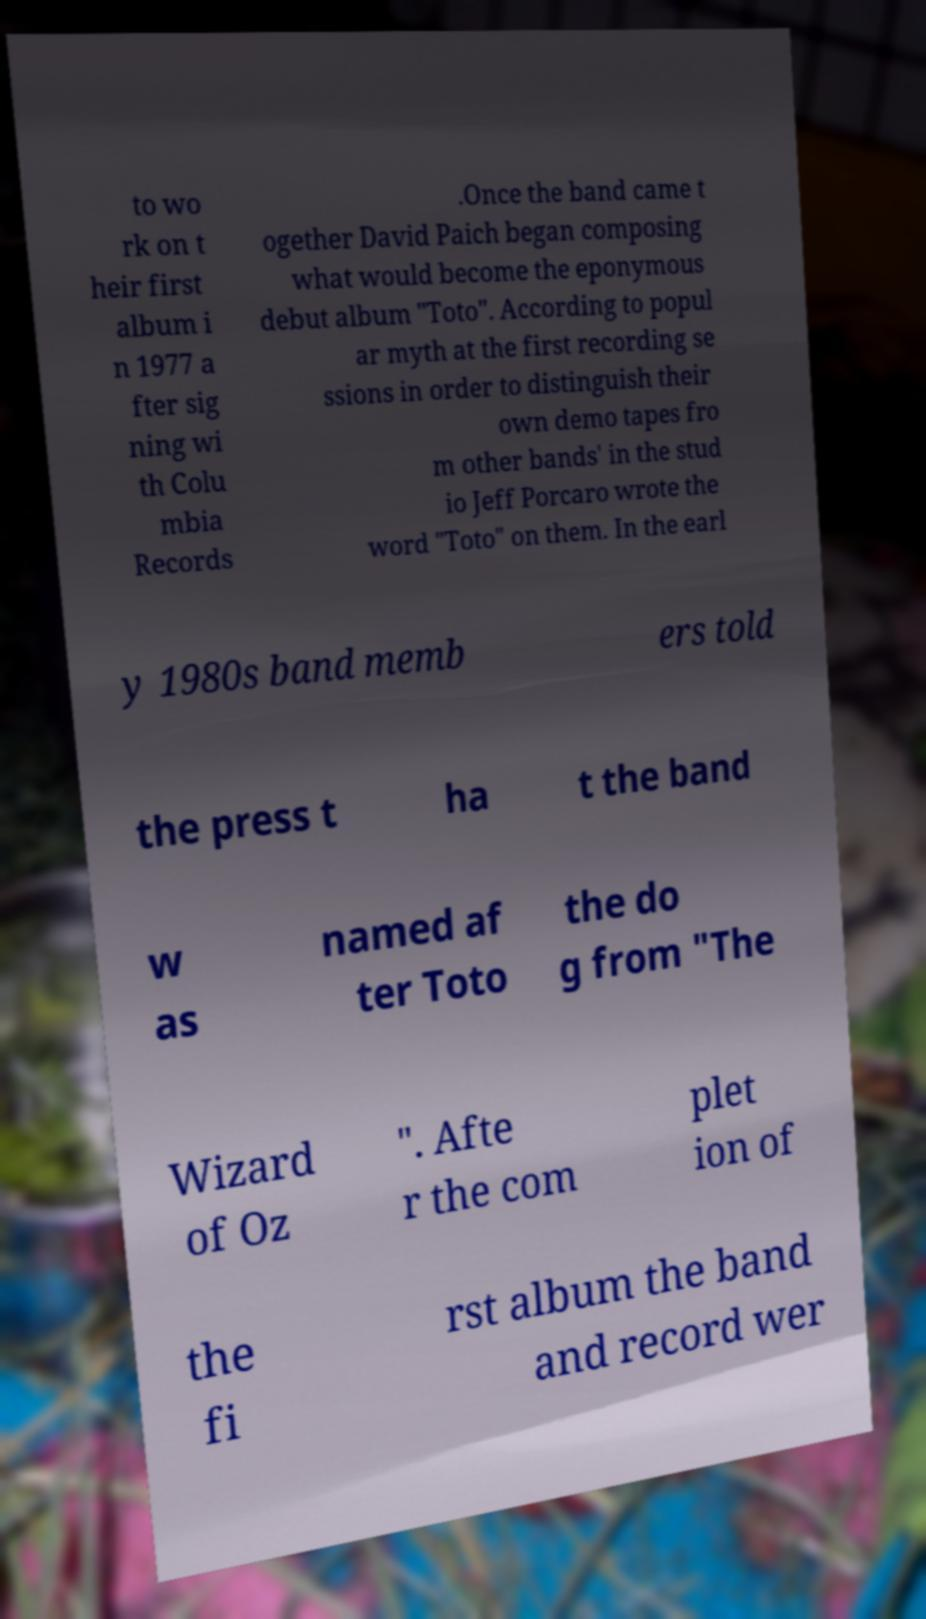I need the written content from this picture converted into text. Can you do that? to wo rk on t heir first album i n 1977 a fter sig ning wi th Colu mbia Records .Once the band came t ogether David Paich began composing what would become the eponymous debut album "Toto". According to popul ar myth at the first recording se ssions in order to distinguish their own demo tapes fro m other bands' in the stud io Jeff Porcaro wrote the word "Toto" on them. In the earl y 1980s band memb ers told the press t ha t the band w as named af ter Toto the do g from "The Wizard of Oz ". Afte r the com plet ion of the fi rst album the band and record wer 